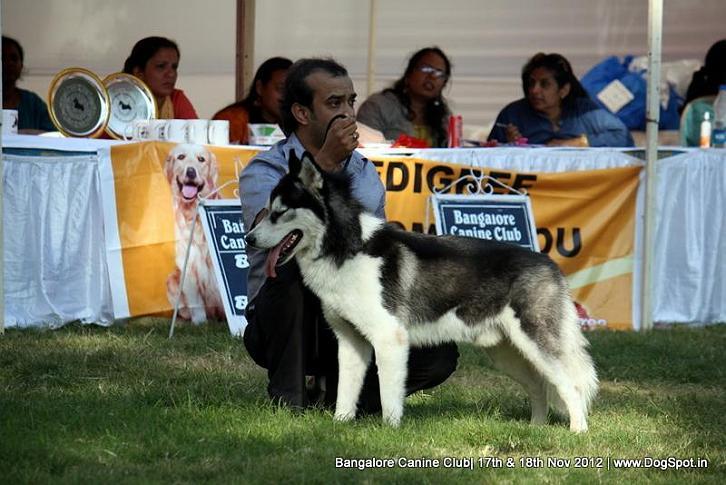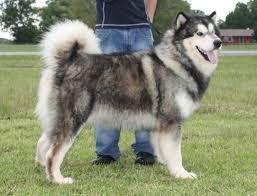The first image is the image on the left, the second image is the image on the right. Examine the images to the left and right. Is the description "The right image features one person standing behind a dog standing in profile, and the left image includes a person crouching behind a dog." accurate? Answer yes or no. Yes. The first image is the image on the left, the second image is the image on the right. Assess this claim about the two images: "The left and right image contains the same number of huskies.". Correct or not? Answer yes or no. Yes. 